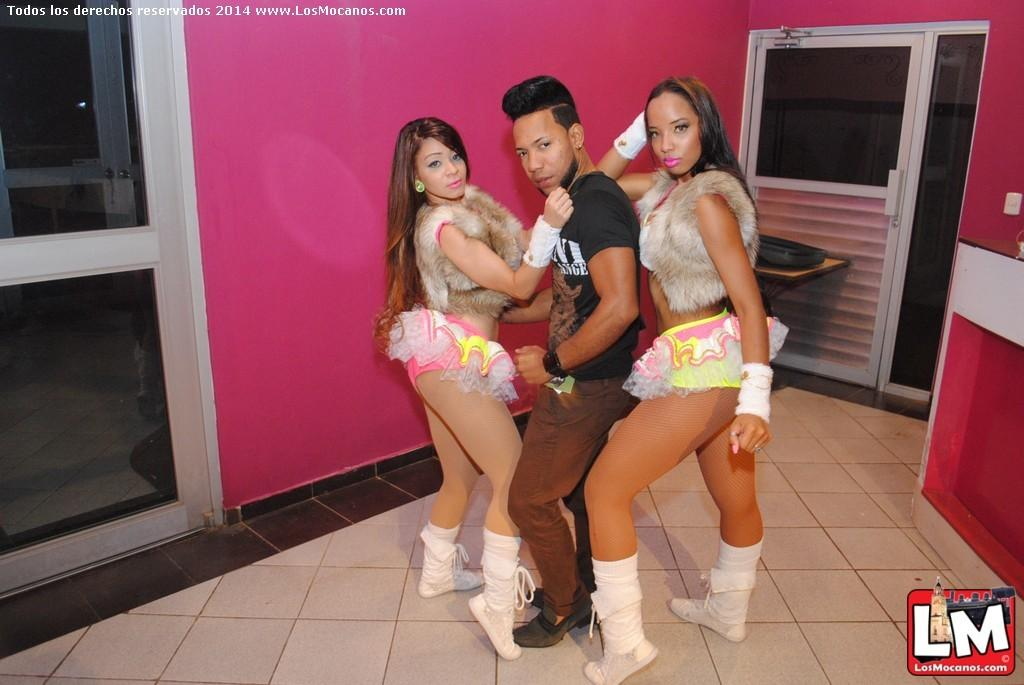How many people are in the image? There are three people in the image: one man and two women. What are the people in the image doing? The man and women are standing. What can be seen in the background of the image? There is a wall and doors in the background of the image. Are there any marks or identifiers on the image itself? Yes, there are watermarks in the top left and bottom right corners of the image. What type of yoke is the man wearing in the image? There is no yoke present in the image; the man is not wearing any such item. 